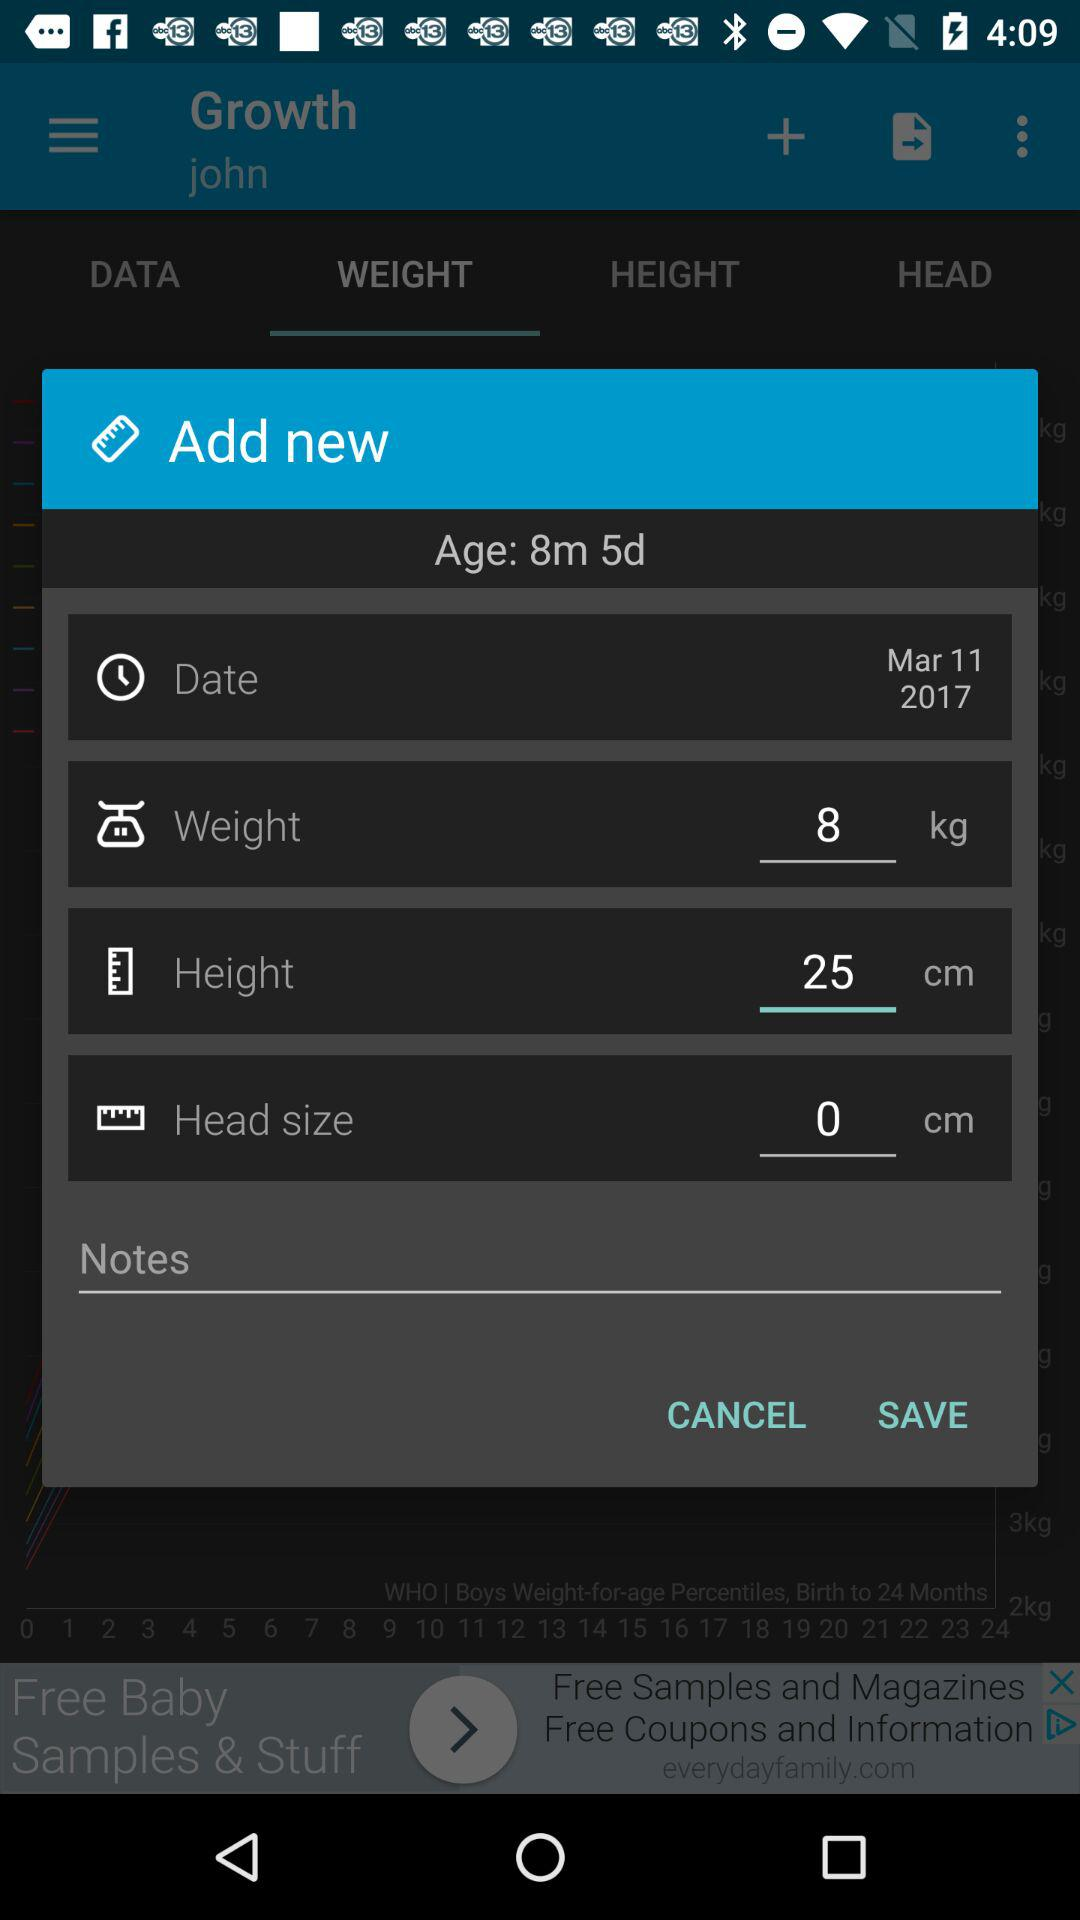What is the height selected on the option? The selected height is 25 cm. 